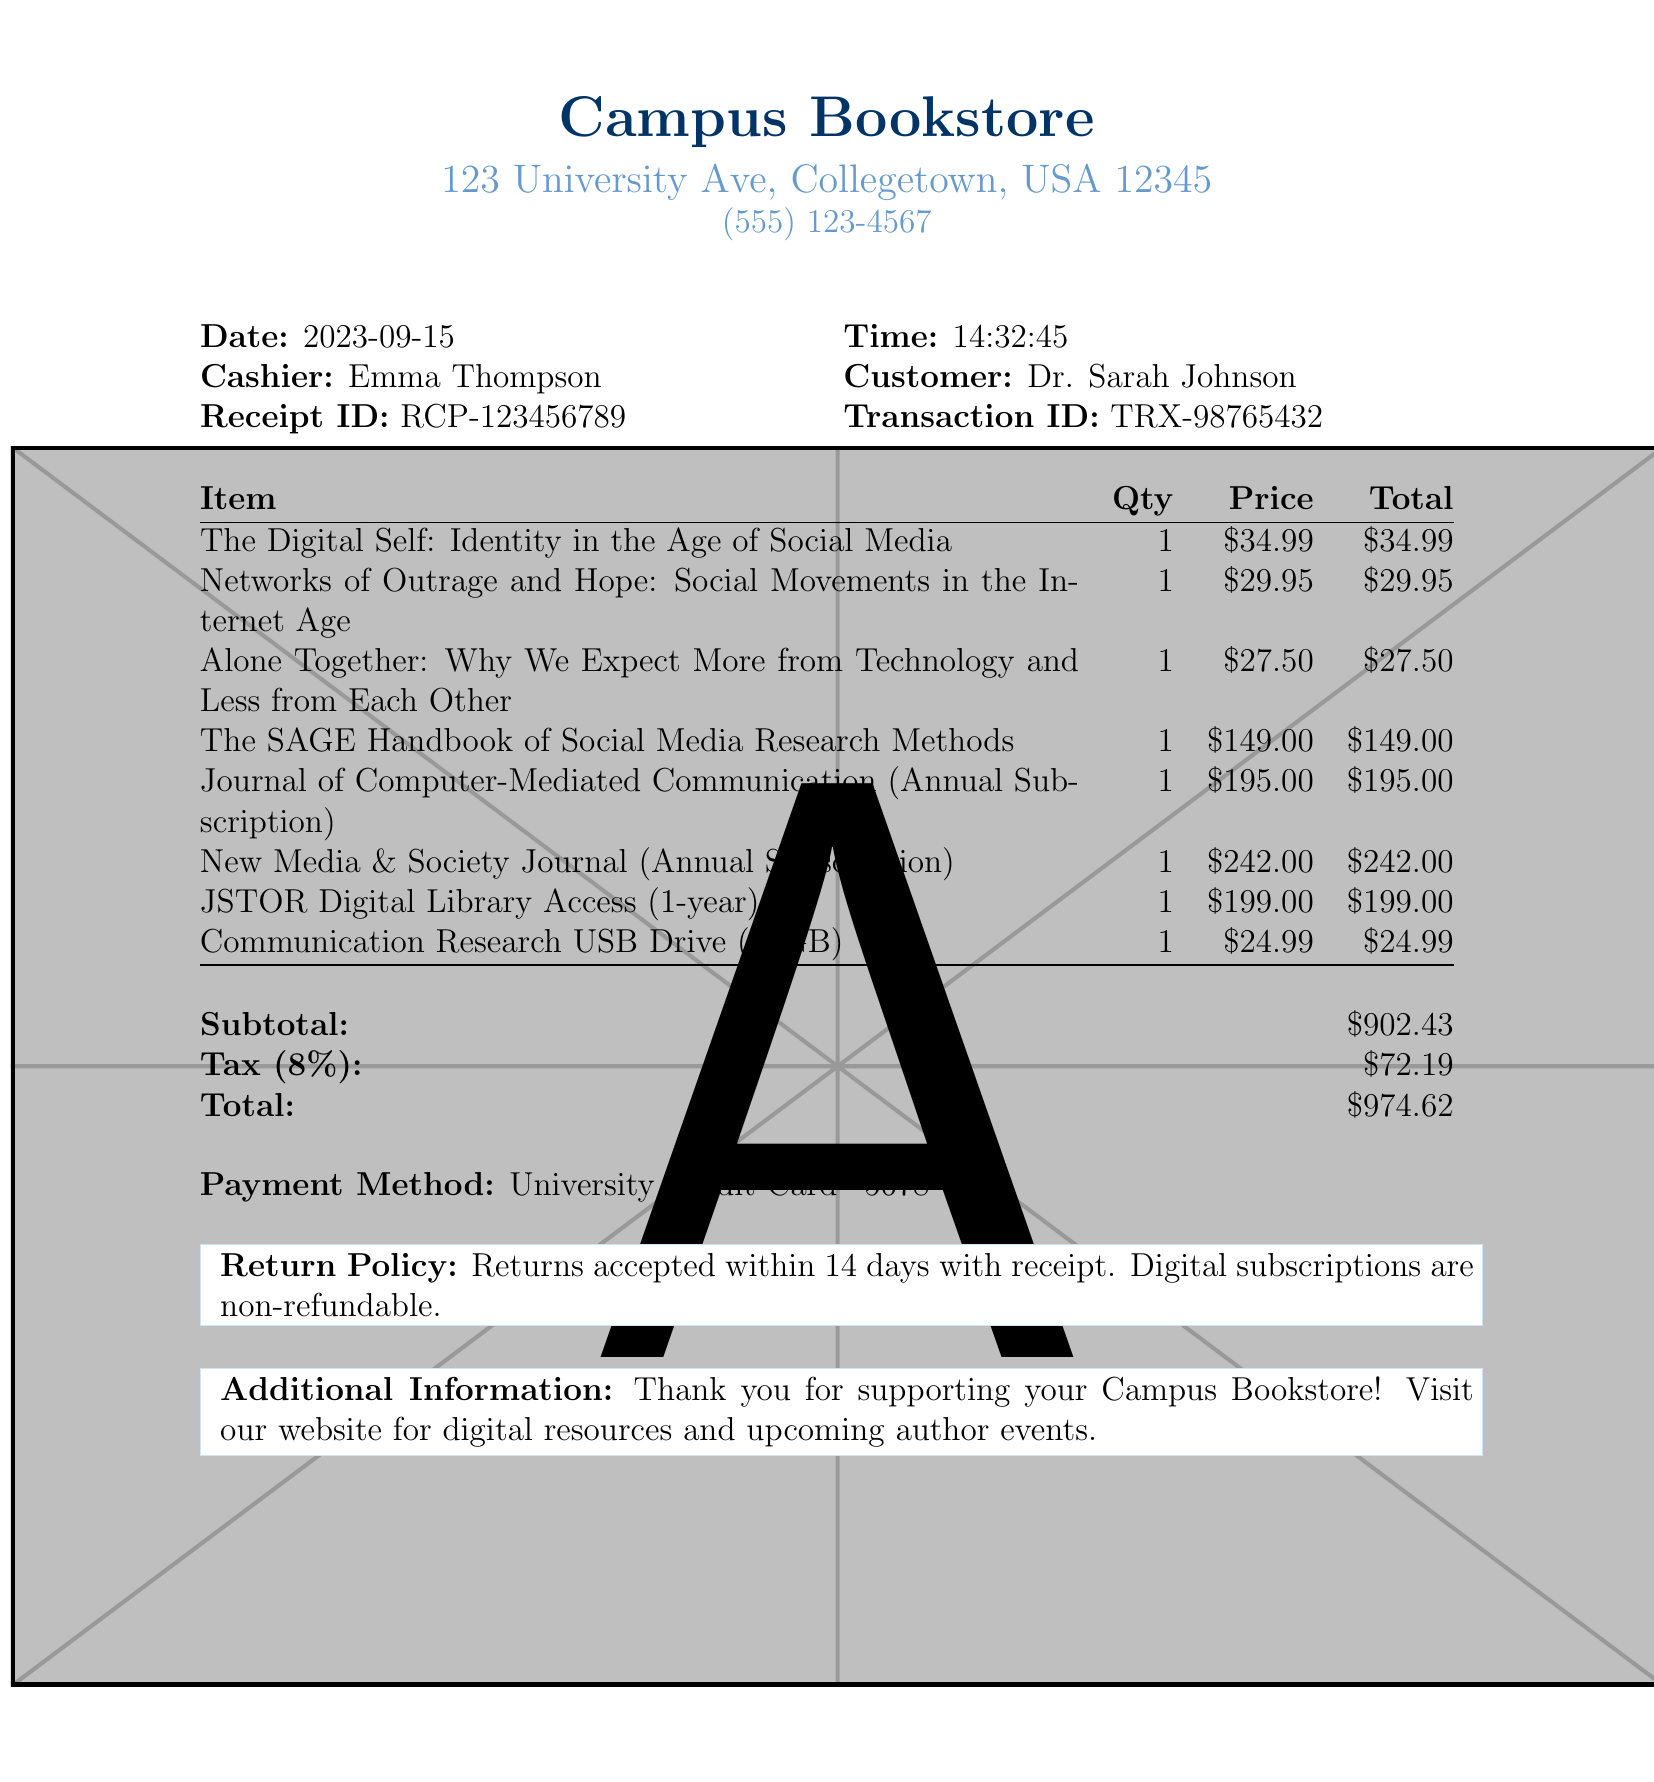What is the name of the bookstore? The name of the bookstore is mentioned at the top of the receipt.
Answer: Campus Bookstore Who is the customer? The customer's name is listed near the cashier information on the receipt.
Answer: Dr. Sarah Johnson What is the total amount spent? The total amount is calculated and shown at the end of the receipt.
Answer: $974.62 How many digital subscriptions were purchased? The items listed include digital subscriptions, which can be counted for a total.
Answer: 3 What is the date of the purchase? The date is specifically mentioned in the document.
Answer: 2023-09-15 What is the return policy for digital subscriptions? The receipt states specific conditions regarding returns, particularly for digital subscriptions.
Answer: Non-refundable What is the tax rate applied to the purchase? The tax rate is stated clearly within the totals section of the receipt.
Answer: 8% Who was the cashier at the time of purchase? The cashier's name is provided in the receipt details.
Answer: Emma Thompson What type of payment method was used? The payment method is specified in the transaction details on the receipt.
Answer: University Credit Card 